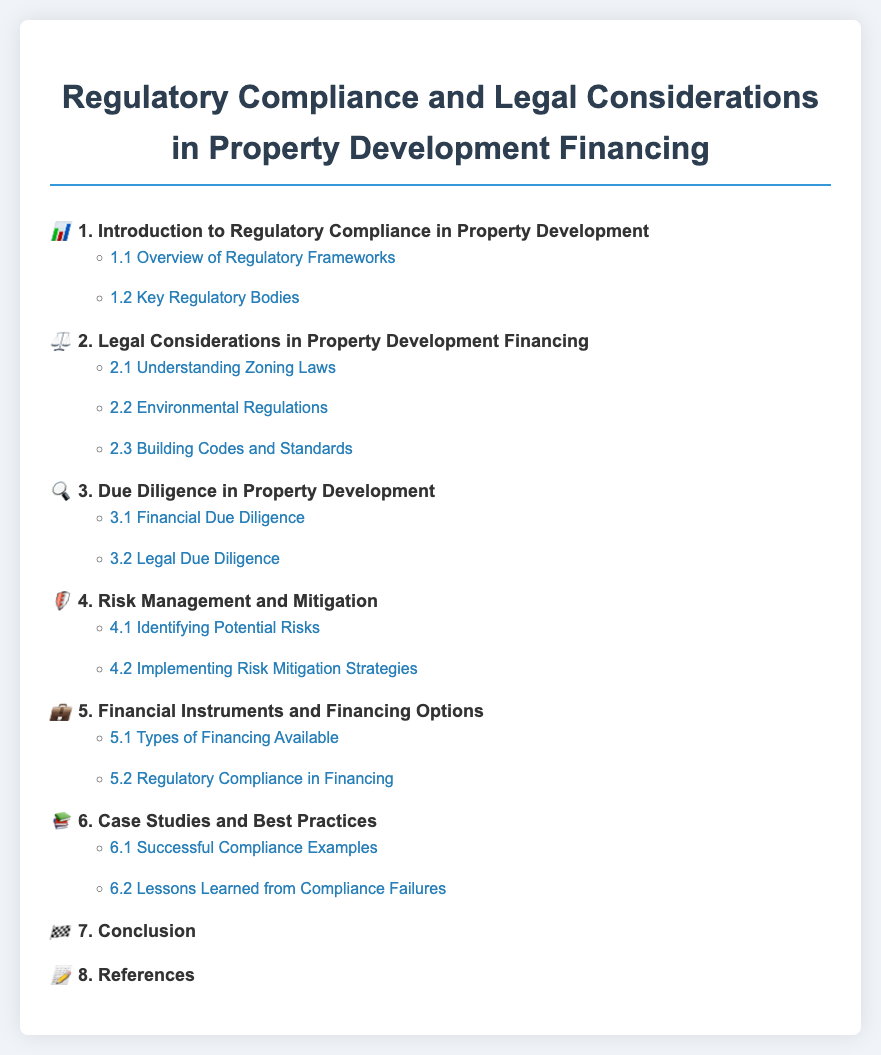what is the title of the document? The title of the document is displayed prominently at the top of the page as the main heading.
Answer: Regulatory Compliance and Legal Considerations in Property Development Financing how many main sections are in the table of contents? The number of main sections can be counted from the list in the table of contents.
Answer: 8 what is the first subsection under Legal Considerations in Property Development Financing? The first subsection is found under the second main section of the table of contents.
Answer: Understanding Zoning Laws what icon represents the section on Due Diligence in Property Development? The icon is illustrated next to the corresponding section title in the table of contents.
Answer: 🔍 what is the last section in the document? The last section can be located at the end of the layout in the table of contents.
Answer: References which section includes examples of compliance failures? This information can be found in the case studies related section of the table of contents.
Answer: Lessons Learned from Compliance Failures 